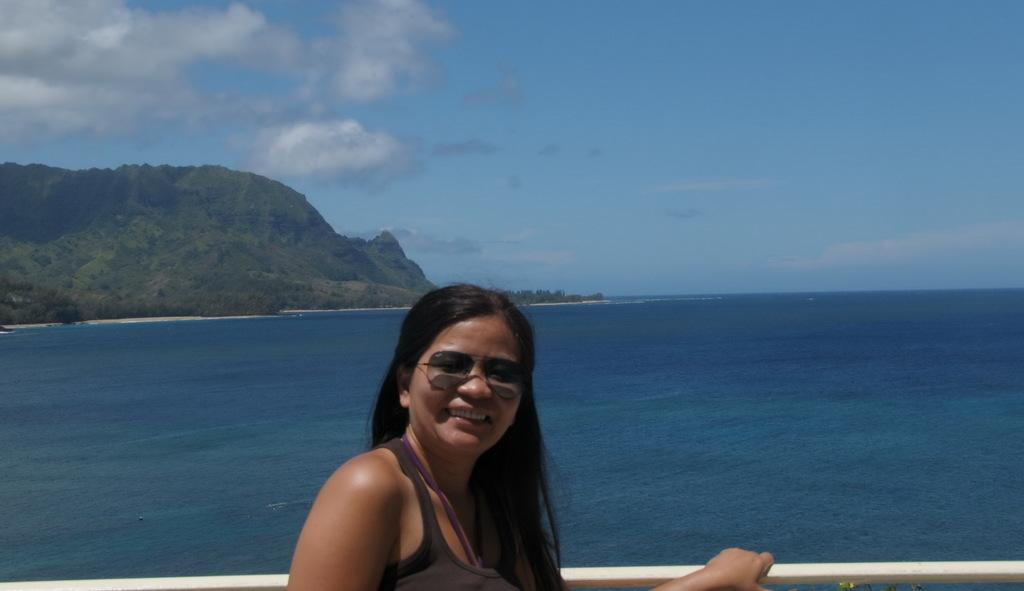Who is present in the image? There is a woman in the image. What is the woman wearing? The woman is wearing clothes and goggles. What is the woman's facial expression? The woman is smiling. What can be seen in the background of the image? There is sea visible in the image, as well as a hill. How would you describe the weather in the image? The sky is cloudy in the image. What type of butter is being used to quiet the curtain in the image? There is no butter or curtain present in the image. 